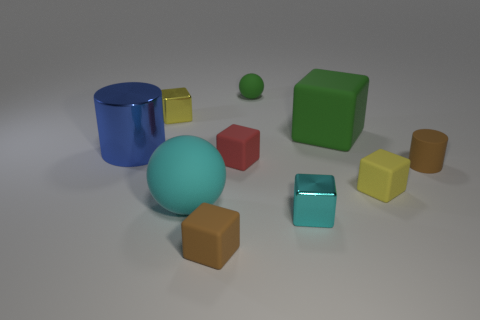Subtract all green blocks. How many blocks are left? 5 Subtract all yellow blocks. How many blocks are left? 4 Subtract all blue blocks. Subtract all red cylinders. How many blocks are left? 6 Subtract all cubes. How many objects are left? 4 Subtract all big metal cylinders. Subtract all large green rubber blocks. How many objects are left? 8 Add 8 rubber cylinders. How many rubber cylinders are left? 9 Add 4 green matte things. How many green matte things exist? 6 Subtract 0 red cylinders. How many objects are left? 10 